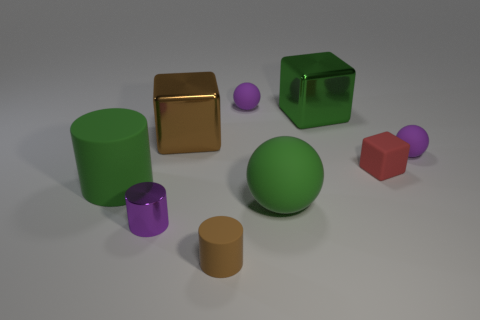Subtract all large brown metal blocks. How many blocks are left? 2 Subtract all purple cylinders. How many purple balls are left? 2 Add 1 brown metal objects. How many objects exist? 10 Subtract 1 cylinders. How many cylinders are left? 2 Subtract all red cylinders. Subtract all yellow blocks. How many cylinders are left? 3 Subtract all cubes. How many objects are left? 6 Subtract 1 purple spheres. How many objects are left? 8 Subtract all big green matte things. Subtract all big cylinders. How many objects are left? 6 Add 3 tiny shiny cylinders. How many tiny shiny cylinders are left? 4 Add 7 purple shiny cylinders. How many purple shiny cylinders exist? 8 